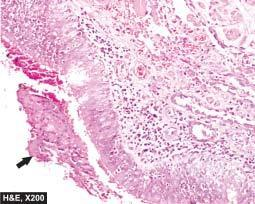s the mucosa sloughed off at places with exudate of muco-pus in the lumen?
Answer the question using a single word or phrase. Yes 